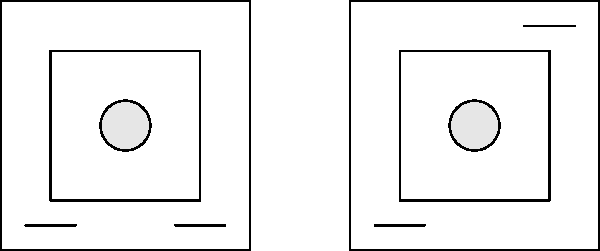Can you spot the difference between these two pictures of the medical technician's workspace? Look closely at the tools on the table! Let's examine the two images step-by-step:

1. Both images show a square representing a table or workspace.
2. Inside each square, there's a smaller square, likely representing a tray or work area.
3. In the center of both images, there's a circle, which might represent a important tool or device.
4. The main difference is in the small lines near the corners of the squares:
   - In the left image, there are two small lines at the bottom: one in the left corner and one in the right corner.
   - In the right image, there's one small line in the bottom left corner, but the second line is now in the top right corner instead of the bottom right.

So, the key difference is that one of the small lines (possibly representing a tool) has moved from the bottom right to the top right in the second image.
Answer: A tool moved from bottom right to top right. 